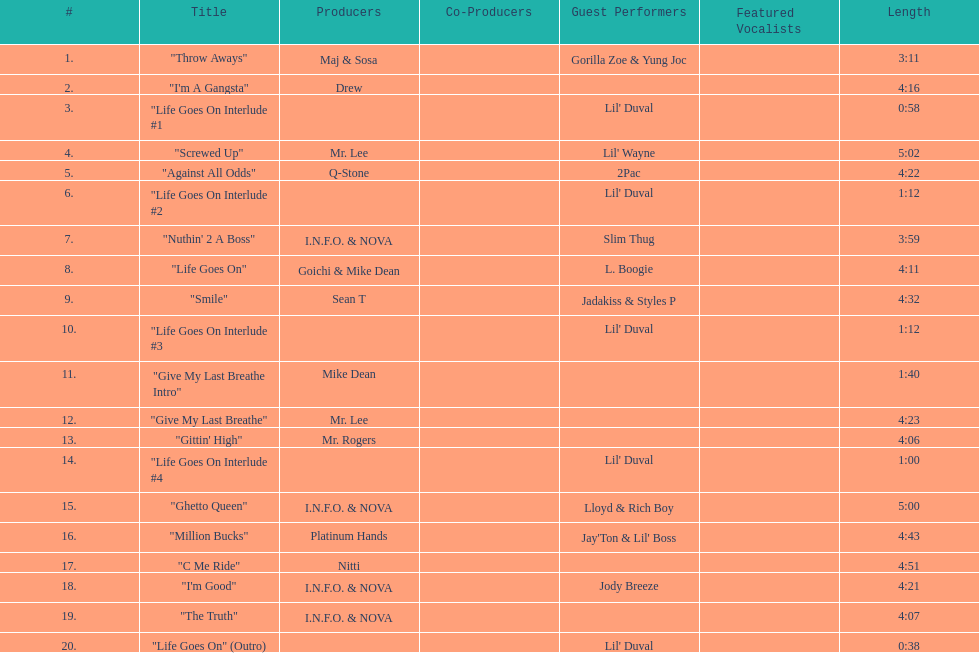How long is track number 11? 1:40. 